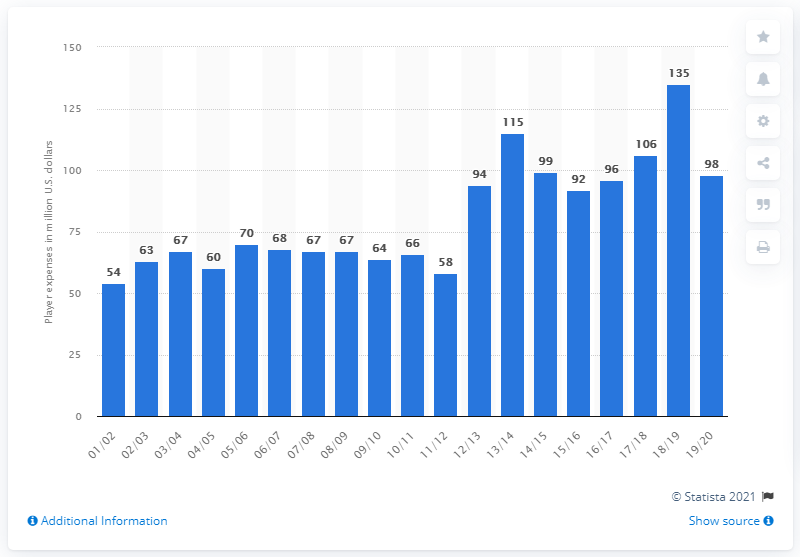Draw attention to some important aspects in this diagram. The player salary of the Brooklyn Nets in the 2019/20 season was 98.. 